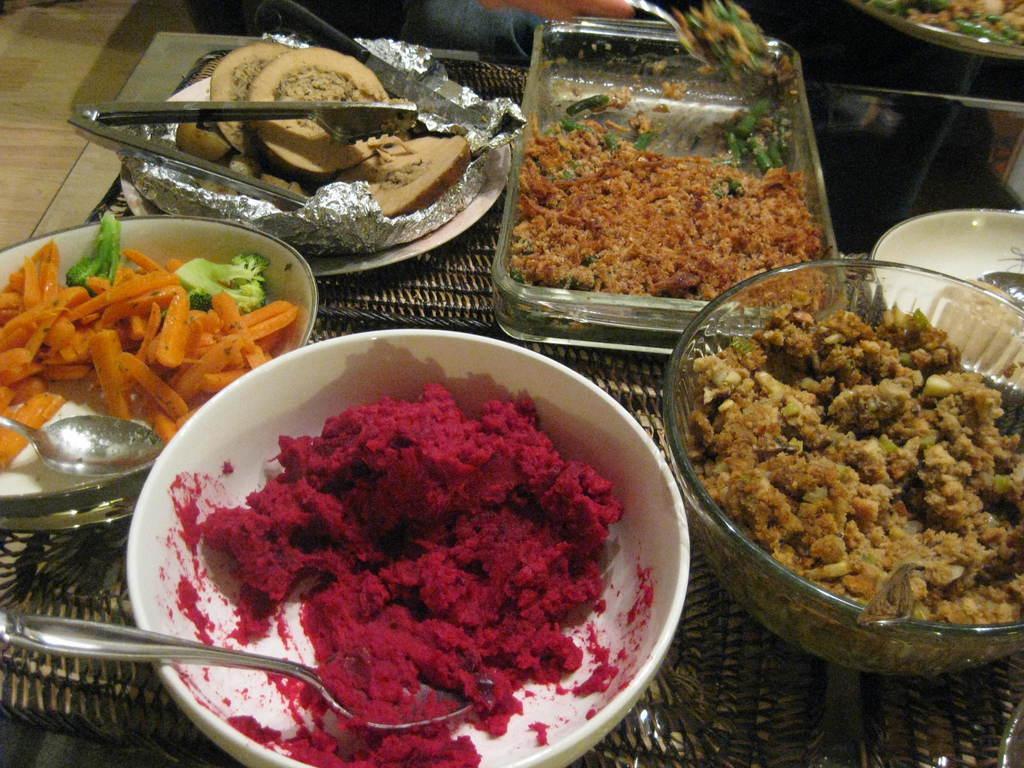Please provide a concise description of this image. In this picture we can see bowls, plates and a tray on an object and on the plates and bowls there are some food items, spoons and an aluminum foil. 